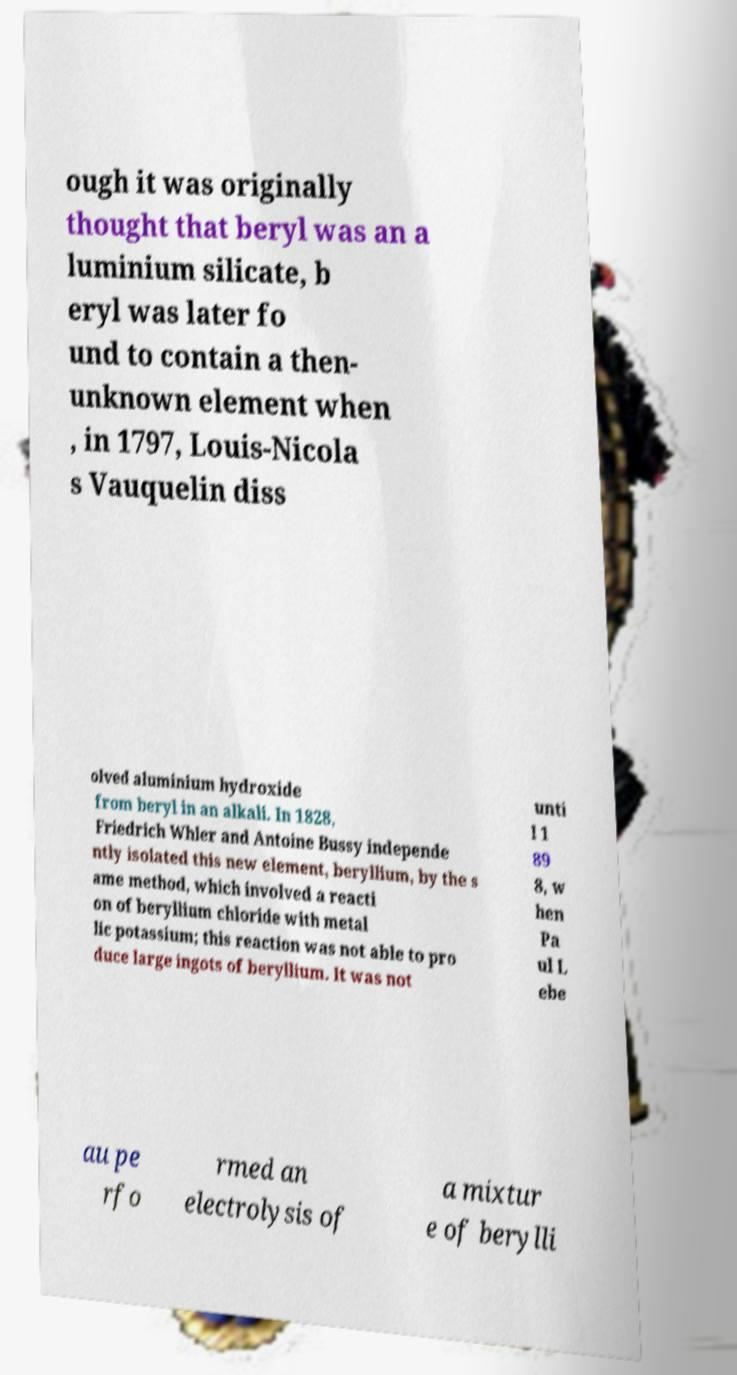Can you accurately transcribe the text from the provided image for me? ough it was originally thought that beryl was an a luminium silicate, b eryl was later fo und to contain a then- unknown element when , in 1797, Louis-Nicola s Vauquelin diss olved aluminium hydroxide from beryl in an alkali. In 1828, Friedrich Whler and Antoine Bussy independe ntly isolated this new element, beryllium, by the s ame method, which involved a reacti on of beryllium chloride with metal lic potassium; this reaction was not able to pro duce large ingots of beryllium. It was not unti l 1 89 8, w hen Pa ul L ebe au pe rfo rmed an electrolysis of a mixtur e of berylli 